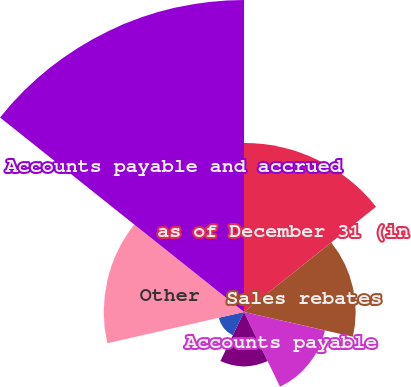Convert chart to OTSL. <chart><loc_0><loc_0><loc_500><loc_500><pie_chart><fcel>as of December 31 (in<fcel>Sales rebates<fcel>Accounts payable<fcel>Salaries wages and commissions<fcel>Royalty license arrangements<fcel>Other<fcel>Accounts payable and accrued<nl><fcel>18.85%<fcel>12.46%<fcel>9.27%<fcel>6.07%<fcel>2.88%<fcel>15.65%<fcel>34.82%<nl></chart> 